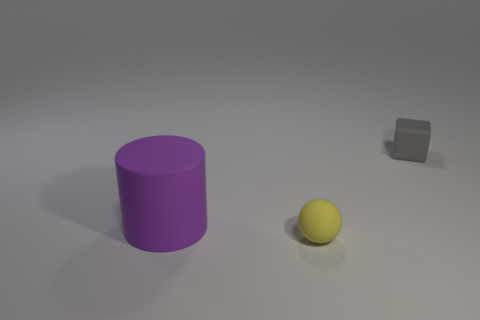Are there any tiny blocks left of the cube?
Make the answer very short. No. How many other objects are the same shape as the gray object?
Your answer should be compact. 0. What color is the sphere that is the same size as the gray matte object?
Make the answer very short. Yellow. Is the number of spheres left of the cylinder less than the number of spheres right of the matte sphere?
Give a very brief answer. No. What number of matte objects are in front of the small matte thing that is in front of the gray matte cube that is behind the small matte sphere?
Give a very brief answer. 0. Is there anything else that has the same size as the yellow matte object?
Make the answer very short. Yes. Are there fewer purple matte objects that are right of the sphere than cylinders?
Provide a short and direct response. Yes. Is the purple rubber thing the same shape as the small gray object?
Offer a terse response. No. How many other matte blocks are the same color as the tiny block?
Provide a short and direct response. 0. What number of things are small matte objects that are on the left side of the block or big yellow matte blocks?
Offer a very short reply. 1. 